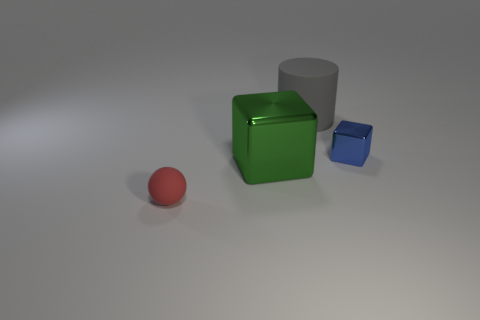Add 4 green objects. How many objects exist? 8 Subtract all cylinders. How many objects are left? 3 Add 2 large red shiny spheres. How many large red shiny spheres exist? 2 Subtract 0 purple spheres. How many objects are left? 4 Subtract all small rubber things. Subtract all blue metal things. How many objects are left? 2 Add 2 metal cubes. How many metal cubes are left? 4 